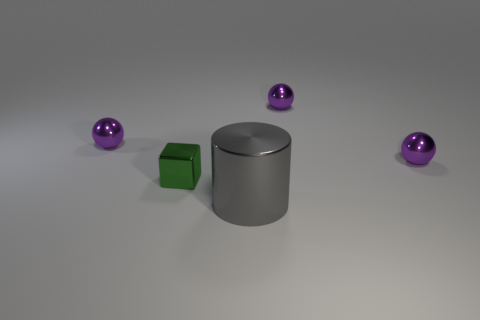There is a purple object that is to the left of the small green metal block; is its size the same as the gray object in front of the green metallic block?
Offer a terse response. No. Is there a tiny green thing of the same shape as the large gray thing?
Ensure brevity in your answer.  No. Are there the same number of tiny purple things that are to the left of the tiny green thing and metal objects?
Give a very brief answer. No. Is the size of the green metal thing the same as the purple object on the left side of the metallic cylinder?
Provide a short and direct response. Yes. What number of other big gray cylinders have the same material as the big cylinder?
Your answer should be very brief. 0. Does the cylinder have the same size as the shiny cube?
Provide a short and direct response. No. Is there anything else that has the same color as the large cylinder?
Make the answer very short. No. What is the shape of the small object that is both behind the small green cube and on the left side of the big cylinder?
Offer a terse response. Sphere. There is a purple sphere on the left side of the large gray cylinder; what size is it?
Your response must be concise. Small. There is a purple metal thing behind the small purple thing on the left side of the gray object; how many things are left of it?
Your response must be concise. 3. 